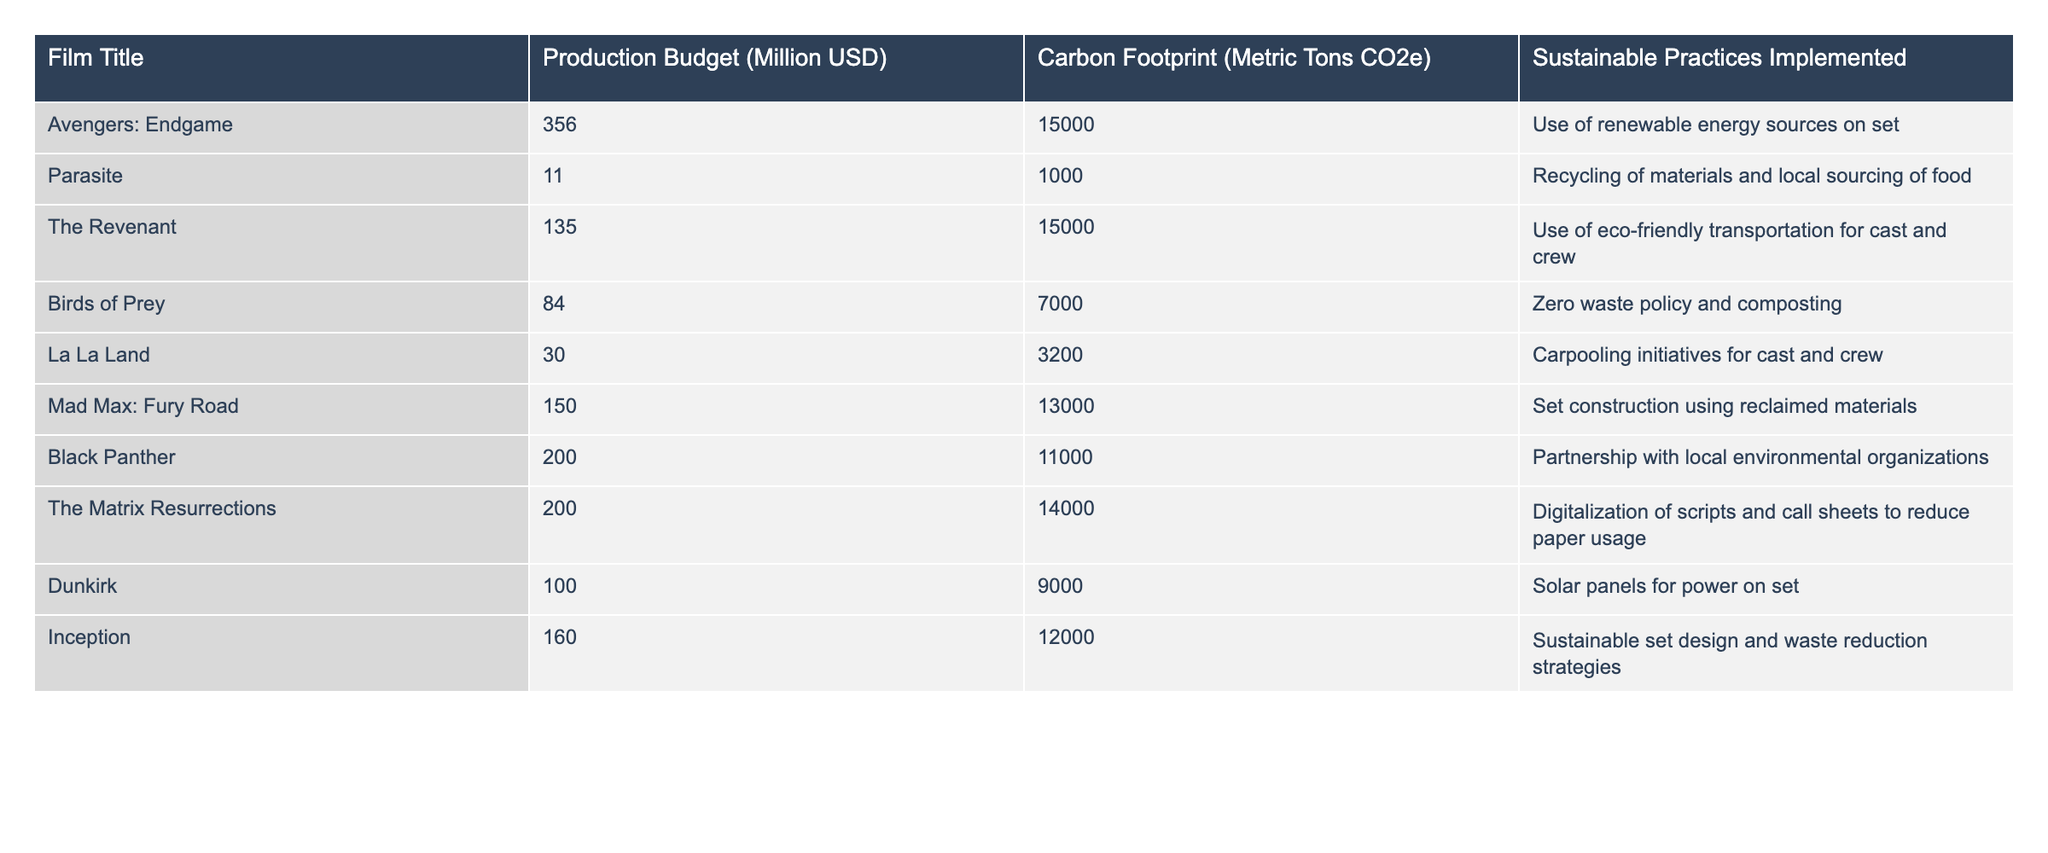What is the production budget of "Parasite"? The table lists the production budget of "Parasite" in the corresponding row, which is 11 million USD.
Answer: 11 million USD Which film has the highest carbon footprint? By looking at the carbon footprint values in the table, "Avengers: Endgame" has the highest value at 15,000 metric tons of CO2e.
Answer: Avengers: Endgame How many films implemented sustainable practices? The table lists sustainable practices for each film. Counting the entries, 10 films have sustainable practices implemented.
Answer: 10 films What is the difference in carbon footprint between "Dunkirk" and "La La Land"? "Dunkirk" has a carbon footprint of 9,000 metric tons CO2e and "La La Land" has 3,200 metric tons. The difference is 9,000 - 3,200 = 5,800 metric tons CO2e.
Answer: 5,800 metric tons CO2e Which film has the lowest production budget and what is it? The production budget for "Parasite" is 11 million USD, the smallest amount in the table, making it the film with the lowest production budget.
Answer: 11 million USD Is "Birds of Prey" more sustainable than "The Revenant"? "Birds of Prey" has a zero waste policy and composting, while "The Revenant" uses eco-friendly transportation only. Both have sustainable practices, but "Birds of Prey" encompasses a broader approach.
Answer: Yes What is the average production budget of the films listed? The total production budget is 1,250 million USD (sum of all budgets), and there are 10 films. Thus, the average is 1,250 / 10 = 125 million USD.
Answer: 125 million USD What percentage of films implemented renewable energy sources on set? There are 10 films in total, and only 1 (Avengers: Endgame) specifically mentions the use of renewable energy, translating to (1/10)*100 = 10%.
Answer: 10% Are there more films with a carbon footprint above 10,000 metric tons or below? Counting from the table, there are 6 films with a carbon footprint above 10,000 metric tons and 4 films below. There are more above 10,000 metric tons.
Answer: More above 10,000 metric tons Which film's sustainable practice focuses on transportation? "The Revenant" specifically mentions using eco-friendly transportation for cast and crew, making it the only film focused on this aspect among the listed sustainable practices.
Answer: The Revenant 